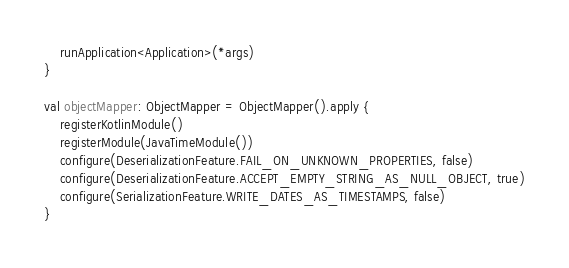<code> <loc_0><loc_0><loc_500><loc_500><_Kotlin_>    runApplication<Application>(*args)
}

val objectMapper: ObjectMapper = ObjectMapper().apply {
    registerKotlinModule()
    registerModule(JavaTimeModule())
    configure(DeserializationFeature.FAIL_ON_UNKNOWN_PROPERTIES, false)
    configure(DeserializationFeature.ACCEPT_EMPTY_STRING_AS_NULL_OBJECT, true)
    configure(SerializationFeature.WRITE_DATES_AS_TIMESTAMPS, false)
}
</code> 